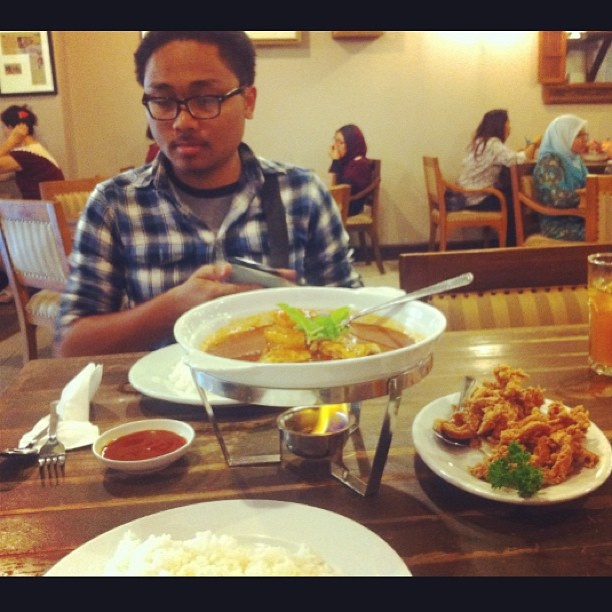Describe the objects in this image and their specific colors. I can see dining table in black, beige, maroon, brown, and tan tones, people in black, gray, maroon, and brown tones, bowl in black, beige, and tan tones, chair in black, maroon, red, and tan tones, and chair in black, darkgray, gray, maroon, and brown tones in this image. 